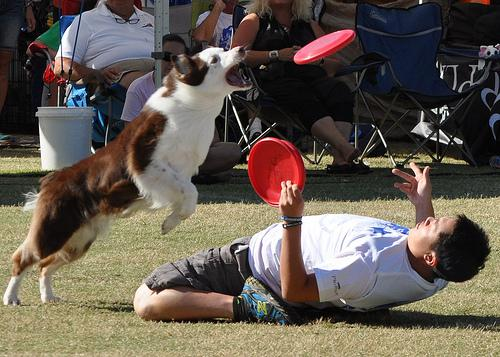Question: who is sitting in the background?
Choices:
A. Crowd.
B. Family.
C. Spectators.
D. Friends.
Answer with the letter. Answer: C Question: who is sliding on the ground?
Choices:
A. A man.
B. A child.
C. A woman.
D. A teenager.
Answer with the letter. Answer: A Question: when is the photo taken?
Choices:
A. Midnight.
B. Evening.
C. Daytime.
D. Noon.
Answer with the letter. Answer: C 